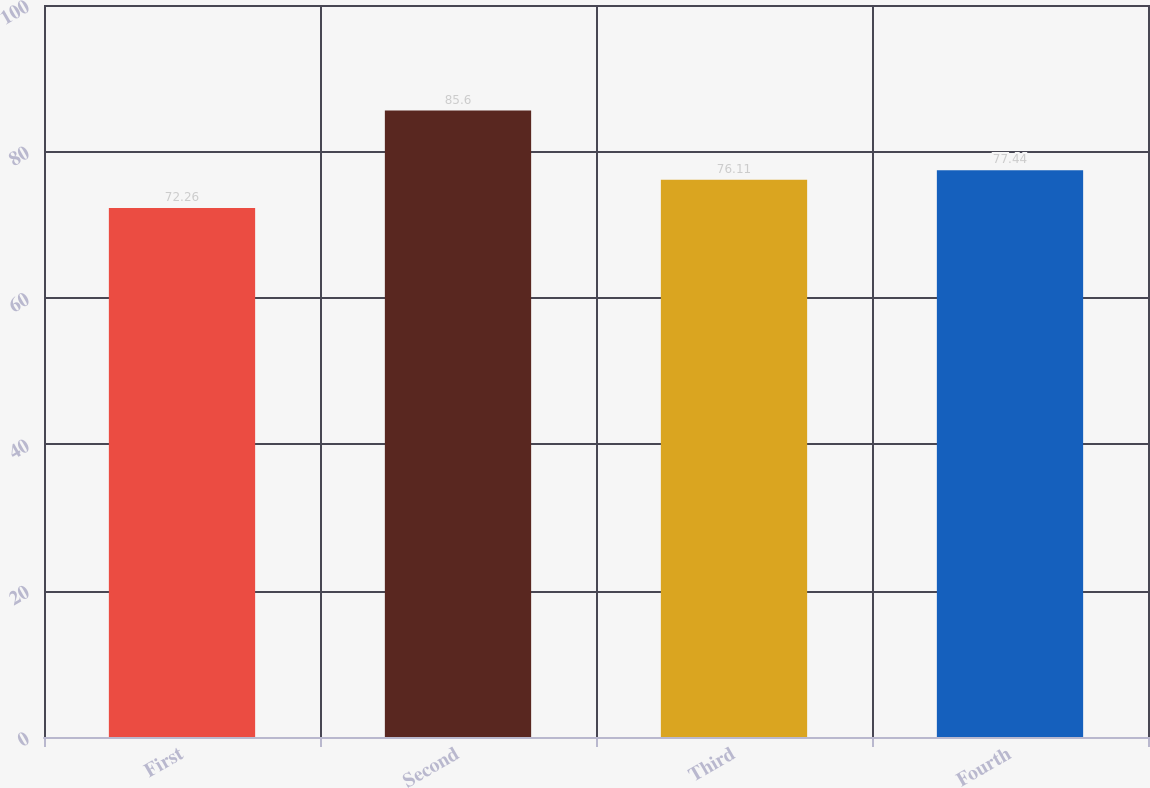<chart> <loc_0><loc_0><loc_500><loc_500><bar_chart><fcel>First<fcel>Second<fcel>Third<fcel>Fourth<nl><fcel>72.26<fcel>85.6<fcel>76.11<fcel>77.44<nl></chart> 